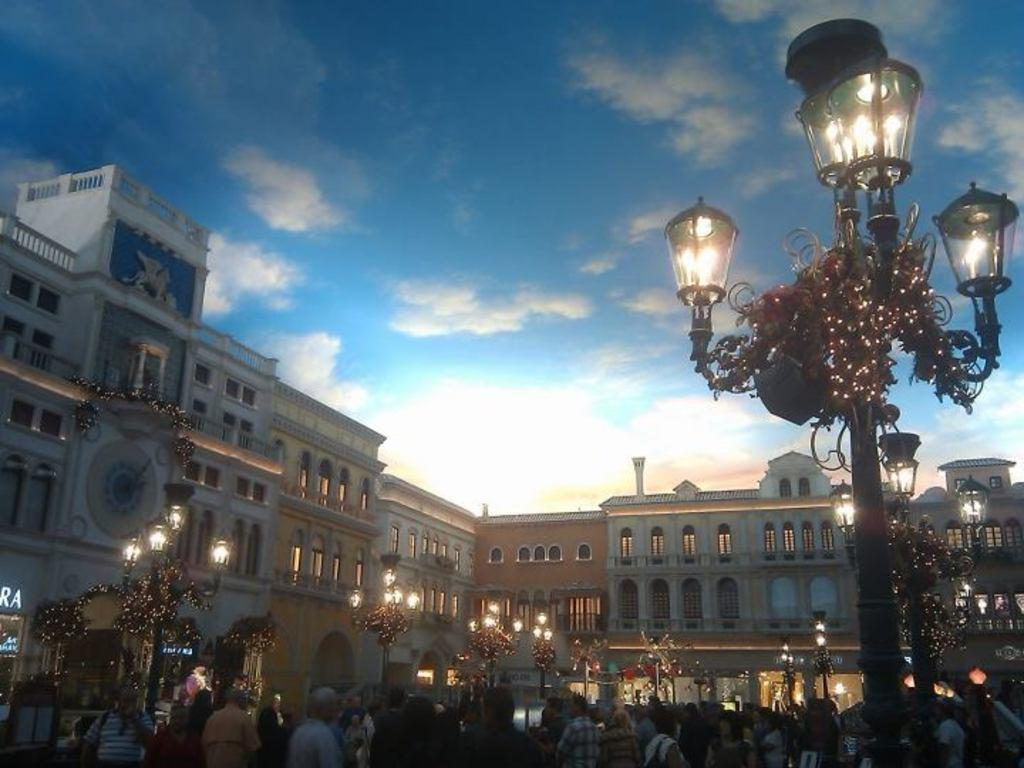How many people are in the image? There are persons standing in the image. What are the metal poles with lights used for in the image? The metal poles with lights are likely used for illumination. What type of structures can be seen in the image? There are buildings in the image. What can be seen in the background of the image? The sky is visible in the background of the image. How long does it take for the beginner to cast a spell in the image? There is no mention of casting spells or beginners in the image; it features persons standing, metal poles with lights, buildings, and the sky. 